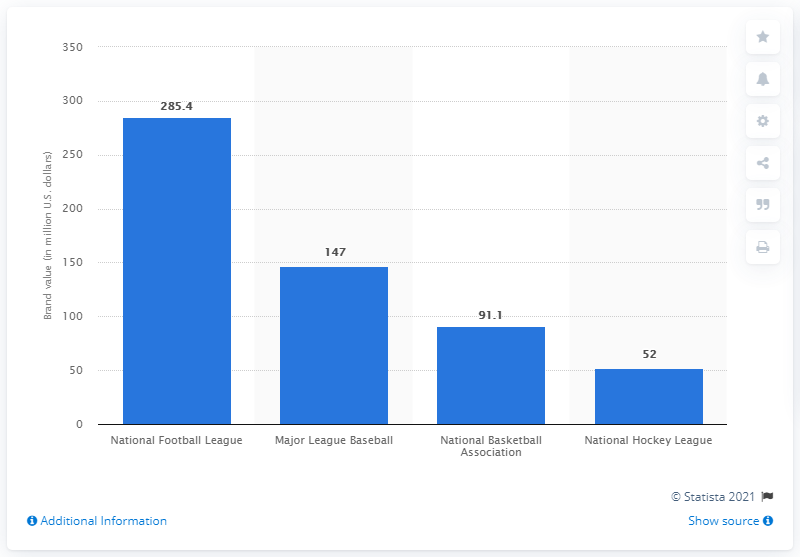Mention a couple of crucial points in this snapshot. The average brand value of the National Football League in 2013 was 285.4. 